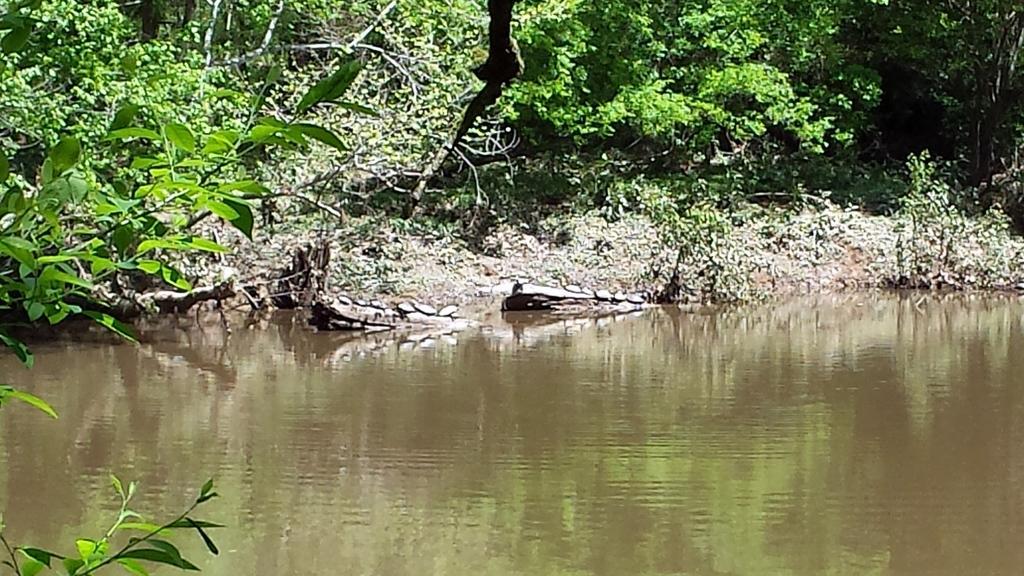In one or two sentences, can you explain what this image depicts? In this image we can see some trees, plants, water and sand. 